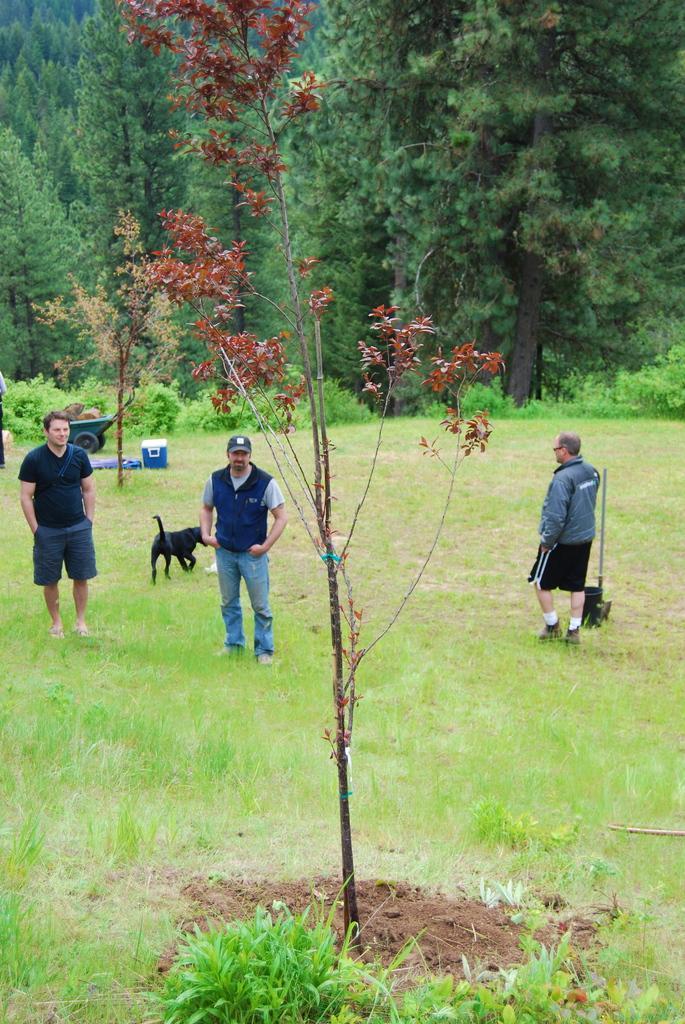Please provide a concise description of this image. In this picture there is grassland in the center of the image and there are people on the right and left side of the image, there are trees in the background area of the image and there is a plant in the center of the image. 